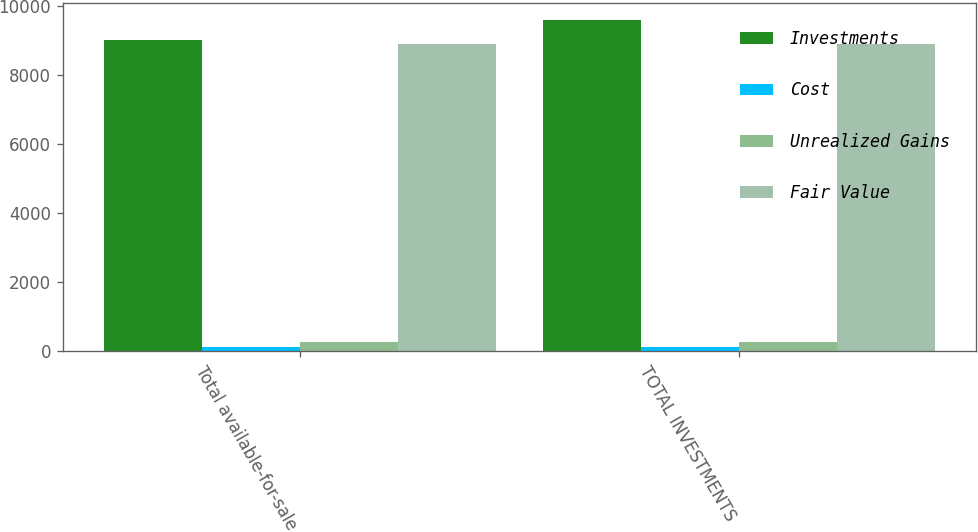Convert chart to OTSL. <chart><loc_0><loc_0><loc_500><loc_500><stacked_bar_chart><ecel><fcel>Total available-for-sale<fcel>TOTAL INVESTMENTS<nl><fcel>Investments<fcel>9008<fcel>9597<nl><fcel>Cost<fcel>127<fcel>127<nl><fcel>Unrealized Gains<fcel>246<fcel>246<nl><fcel>Fair Value<fcel>8889<fcel>8889<nl></chart> 